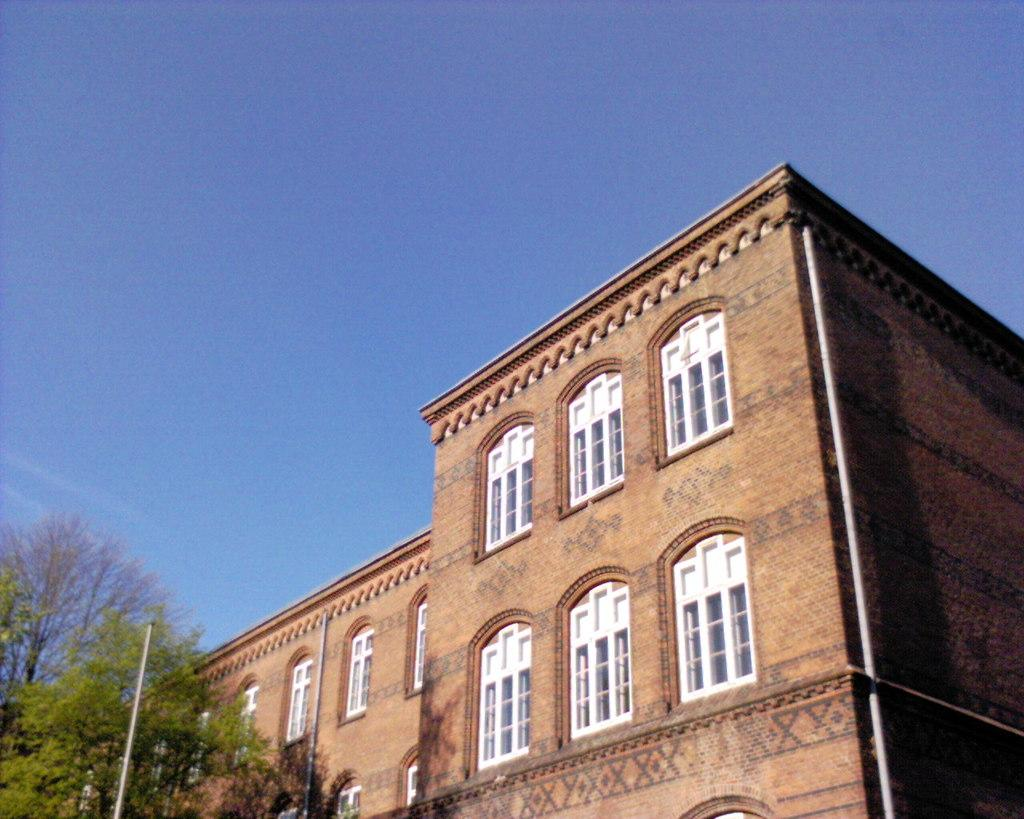What type of structure is present in the image? There is a building in the image. What color is the building? The building is brown. What other objects can be seen in the image? There are trees, a pole, and glass windows in the building. What color are the trees? The trees are green. What color is the pole? The pole is white. What can be seen in the background of the image? The sky is visible in the background of the image. What color is the sky? The sky is blue. Can you tell me how many passengers are sitting on the drum in the image? There is no drum or passengers present in the image. 